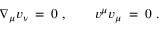Convert formula to latex. <formula><loc_0><loc_0><loc_500><loc_500>\nabla _ { \mu } v _ { \nu } \, = \, 0 \ , \quad \ \ v ^ { \mu } v _ { \mu } \, = \, 0 \ .</formula> 